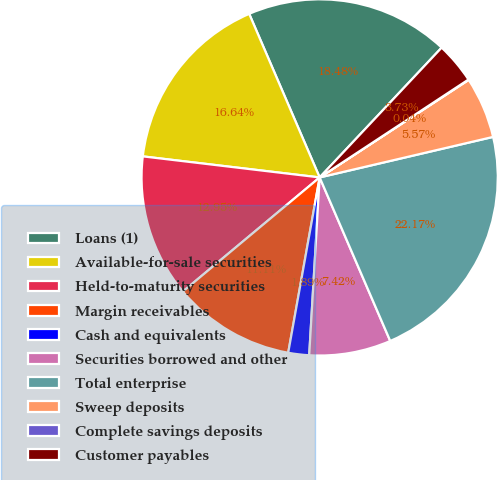<chart> <loc_0><loc_0><loc_500><loc_500><pie_chart><fcel>Loans (1)<fcel>Available-for-sale securities<fcel>Held-to-maturity securities<fcel>Margin receivables<fcel>Cash and equivalents<fcel>Securities borrowed and other<fcel>Total enterprise<fcel>Sweep deposits<fcel>Complete savings deposits<fcel>Customer payables<nl><fcel>18.48%<fcel>16.64%<fcel>12.95%<fcel>11.11%<fcel>1.89%<fcel>7.42%<fcel>22.17%<fcel>5.57%<fcel>0.04%<fcel>3.73%<nl></chart> 